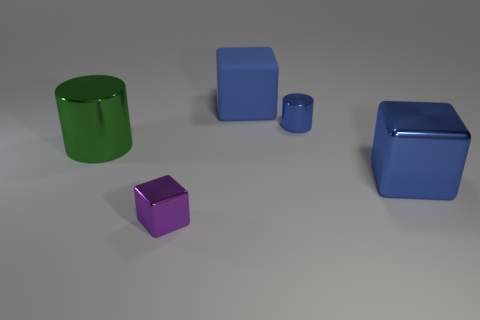Add 2 big green things. How many objects exist? 7 Subtract all large blue metallic cubes. How many cubes are left? 2 Subtract all green cylinders. How many cylinders are left? 1 Subtract 1 cubes. How many cubes are left? 2 Add 3 large green cylinders. How many large green cylinders exist? 4 Subtract 0 red cubes. How many objects are left? 5 Subtract all cylinders. How many objects are left? 3 Subtract all yellow cubes. Subtract all blue cylinders. How many cubes are left? 3 Subtract all gray spheres. How many red blocks are left? 0 Subtract all green things. Subtract all large shiny cubes. How many objects are left? 3 